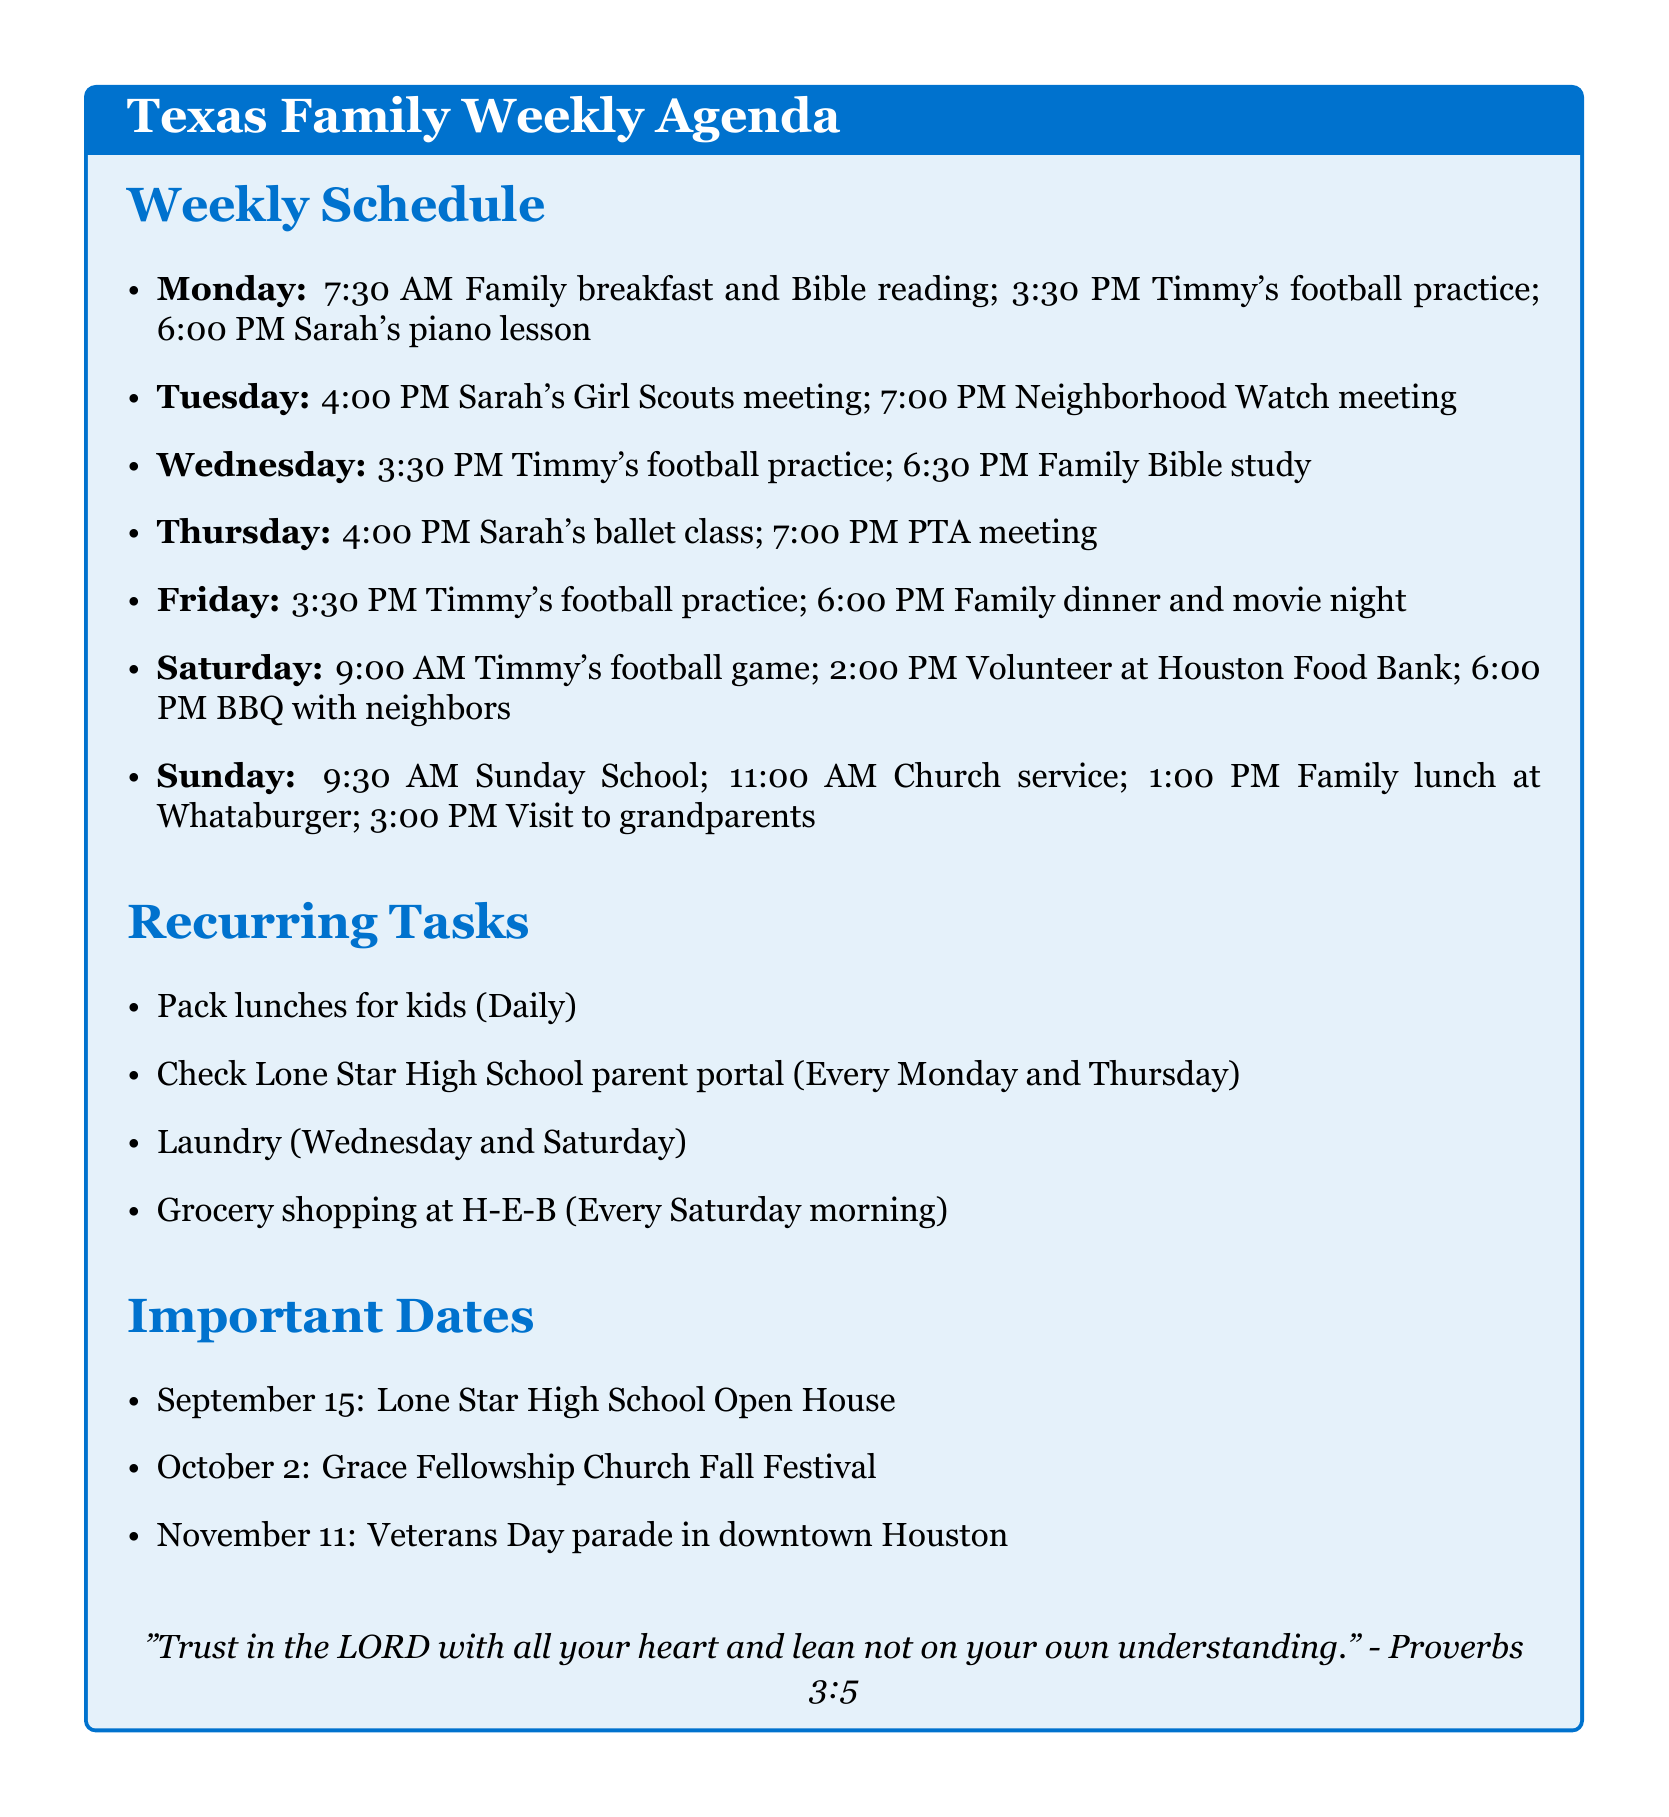what time is Timmy's football practice on Mondays? Timmy's football practice is scheduled every Monday at 3:30 PM.
Answer: 3:30 PM when is the Family Bible study? The Family Bible study occurs on Wednesday at 6:30 PM.
Answer: 6:30 PM what recurring task occurs every Saturday morning? The document states that grocery shopping at H-E-B occurs every Saturday morning.
Answer: Grocery shopping at H-E-B how many times does Timmy have football practice each week? Timmy has football practice three times each week: Monday, Wednesday, and Friday.
Answer: 3 where does Sarah have her ballet class? Sarah's ballet class is held at Texas Dance Academy.
Answer: Texas Dance Academy what activity is planned for Saturday at 2:00 PM? At 2:00 PM on Saturday, the family is volunteering at Houston Food Bank.
Answer: Volunteer at Houston Food Bank when is the Lone Star High School Open House? The Lone Star High School Open House is scheduled for September 15.
Answer: September 15 how often does the family pack lunches for the kids? The family packs lunches for the kids daily.
Answer: Daily what event is scheduled after Sunday School on Sunday? After Sunday School at 9:30 AM, the family attends the church service at 11:00 AM.
Answer: Church service at 11:00 AM 